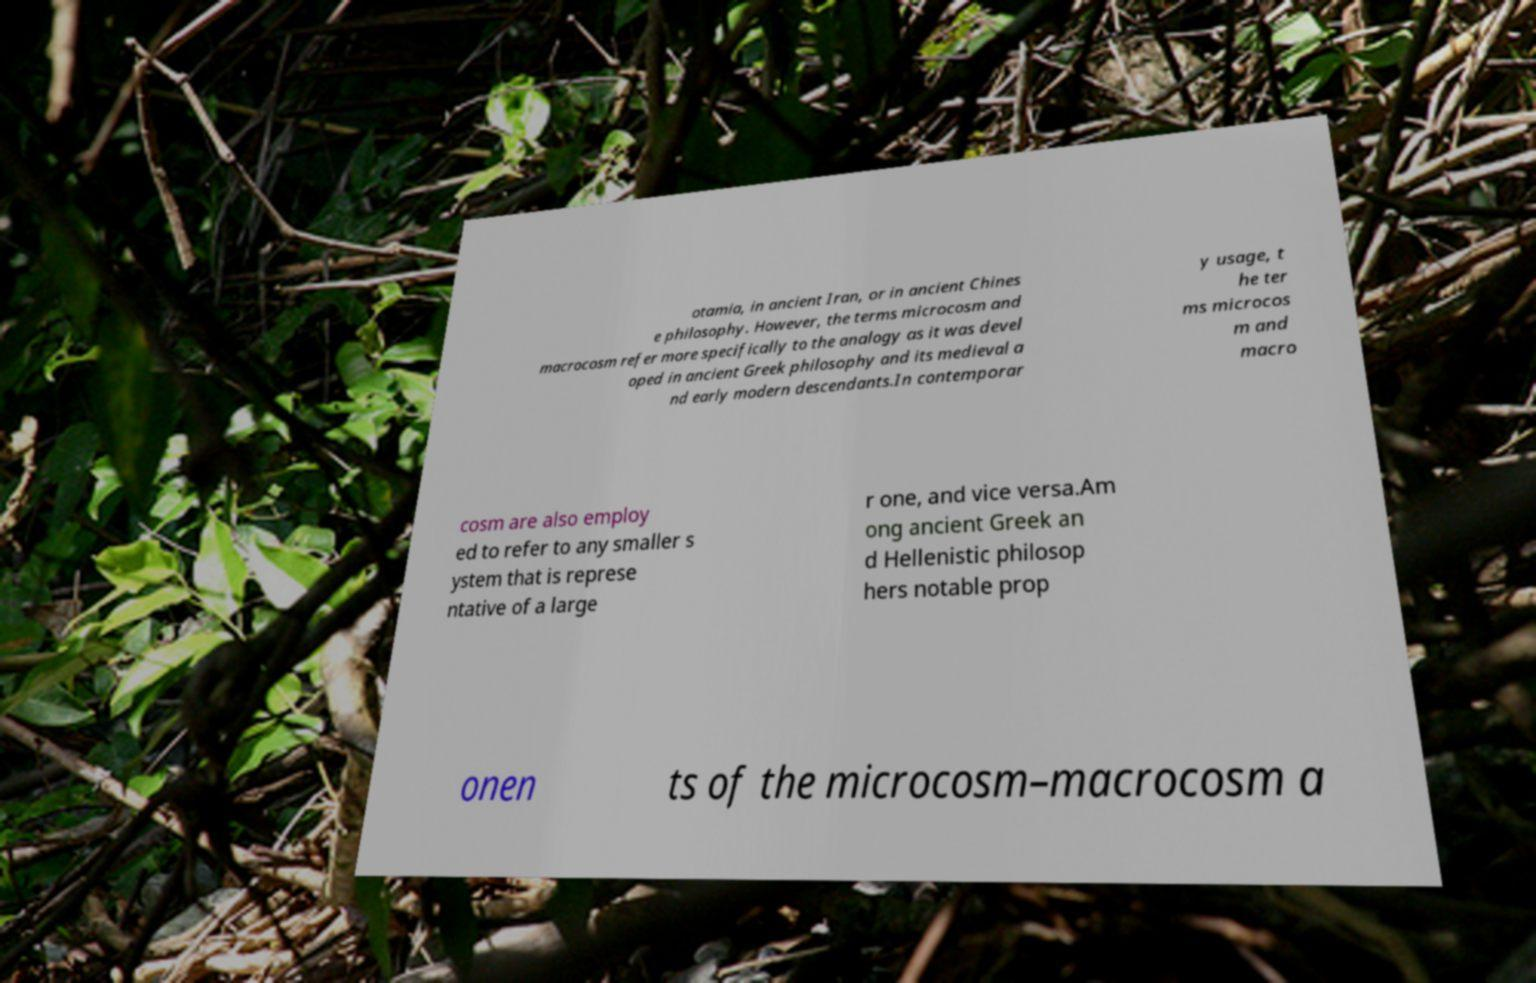For documentation purposes, I need the text within this image transcribed. Could you provide that? otamia, in ancient Iran, or in ancient Chines e philosophy. However, the terms microcosm and macrocosm refer more specifically to the analogy as it was devel oped in ancient Greek philosophy and its medieval a nd early modern descendants.In contemporar y usage, t he ter ms microcos m and macro cosm are also employ ed to refer to any smaller s ystem that is represe ntative of a large r one, and vice versa.Am ong ancient Greek an d Hellenistic philosop hers notable prop onen ts of the microcosm–macrocosm a 